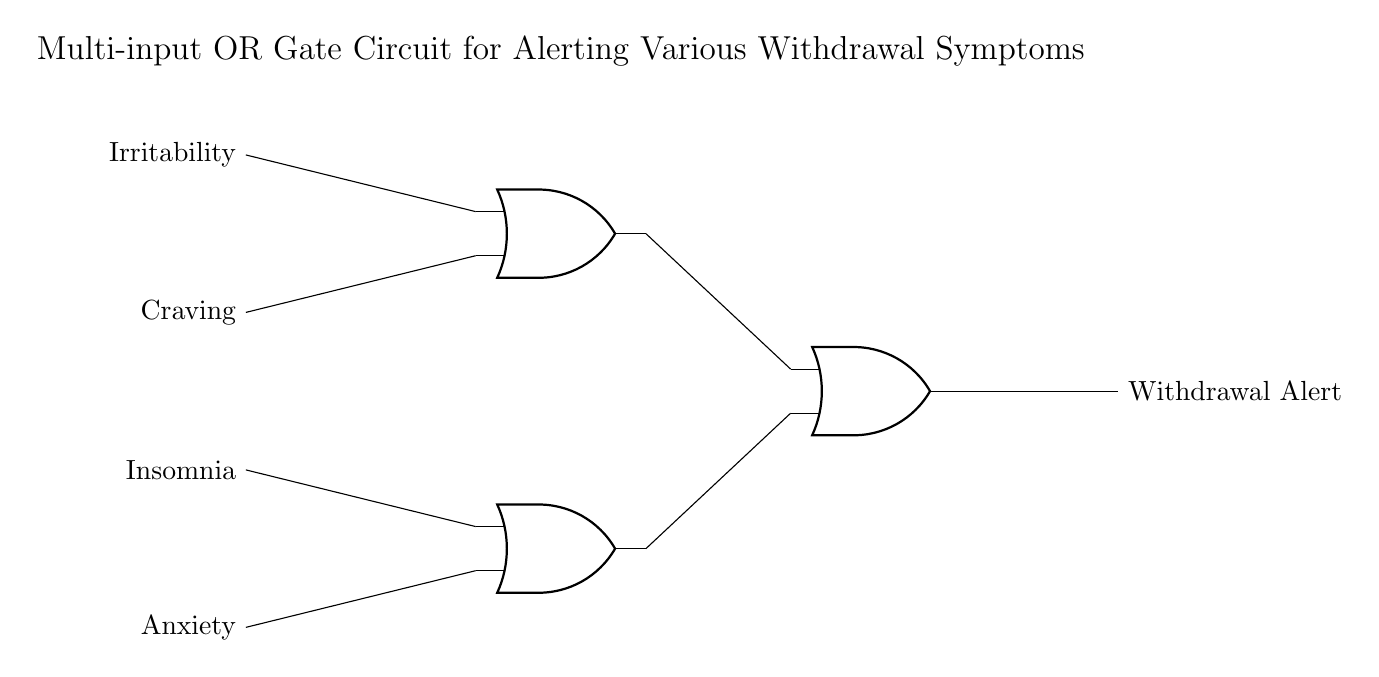What inputs does the OR gate receive? The OR gate receives four inputs: Irritability, Craving, Insomnia, and Anxiety. Each input is connected to the OR gates, indicating that any of these symptoms can trigger the output alert.
Answer: Irritability, Craving, Insomnia, Anxiety How many OR gates are used in the circuit? There are three OR gates in the circuit. The diagram shows two lower-level OR gates that combine to feed into a higher-level OR gate.
Answer: Three What is the function of the output signal? The function of the output signal is to indicate a Withdrawal Alert. It represents that at least one input symptom has been triggered, leading to the output of an alert.
Answer: Withdrawal Alert How many inputs are combined in the final OR gate? The final OR gate combines two inputs from the previous OR gates. This means it takes the outputs of the lower OR gates as its inputs.
Answer: Two What happens if one input is activated? If one input is activated, the output will become active due to the nature of the OR gate. An OR gate generates a high output if any one of its inputs is high.
Answer: Output becomes active What withdrawal symptoms can trigger an alert? The symptoms that can trigger an alert include irritability, craving, insomnia, and anxiety. Each of these can lead to the output signal being generated.
Answer: Irritability, Craving, Insomnia, Anxiety 